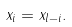<formula> <loc_0><loc_0><loc_500><loc_500>x _ { i } = x _ { l - i } .</formula> 